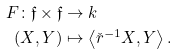<formula> <loc_0><loc_0><loc_500><loc_500>F \colon \mathfrak { f } \times \mathfrak { f } & \to k \\ ( X , Y ) & \mapsto \left < \check { r } ^ { - 1 } X , Y \right > .</formula> 